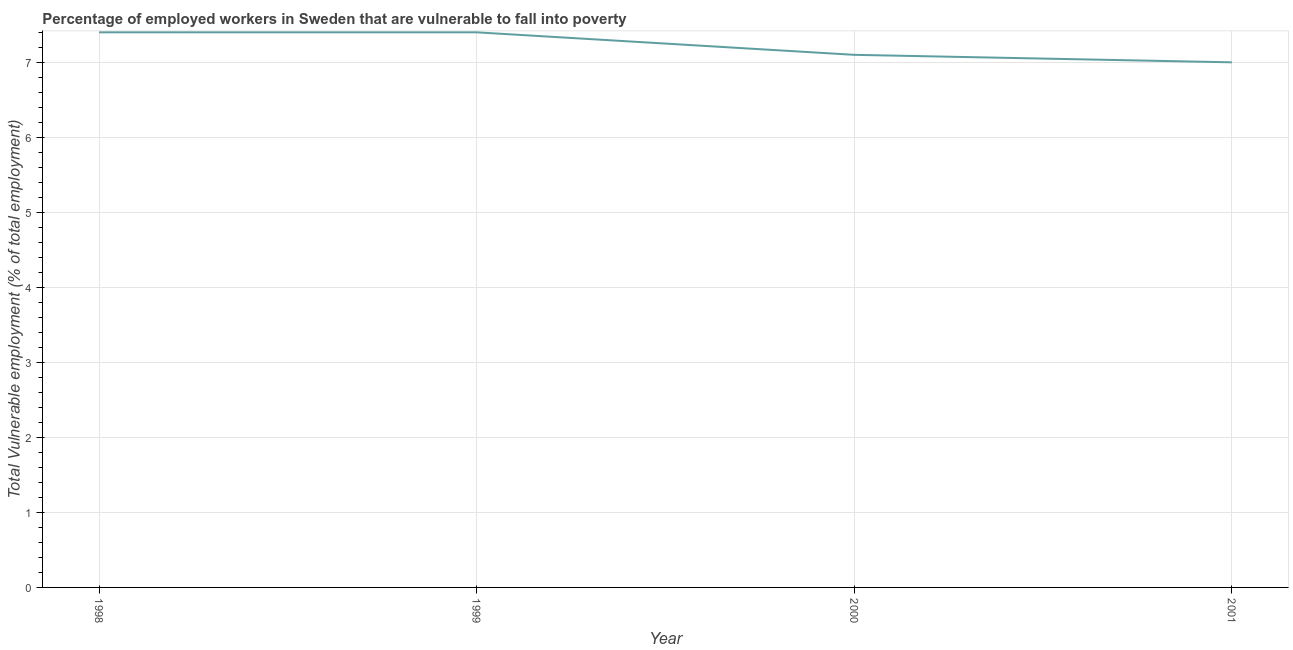What is the total vulnerable employment in 2000?
Provide a succinct answer. 7.1. Across all years, what is the maximum total vulnerable employment?
Give a very brief answer. 7.4. Across all years, what is the minimum total vulnerable employment?
Keep it short and to the point. 7. In which year was the total vulnerable employment minimum?
Your response must be concise. 2001. What is the sum of the total vulnerable employment?
Make the answer very short. 28.9. What is the difference between the total vulnerable employment in 1998 and 2000?
Make the answer very short. 0.3. What is the average total vulnerable employment per year?
Your answer should be compact. 7.23. What is the median total vulnerable employment?
Your answer should be very brief. 7.25. Do a majority of the years between 1999 and 2000 (inclusive) have total vulnerable employment greater than 2.8 %?
Provide a short and direct response. Yes. Is the difference between the total vulnerable employment in 1998 and 2001 greater than the difference between any two years?
Ensure brevity in your answer.  Yes. Is the sum of the total vulnerable employment in 2000 and 2001 greater than the maximum total vulnerable employment across all years?
Provide a succinct answer. Yes. What is the difference between the highest and the lowest total vulnerable employment?
Provide a succinct answer. 0.4. Does the total vulnerable employment monotonically increase over the years?
Provide a short and direct response. No. How many lines are there?
Your response must be concise. 1. Does the graph contain grids?
Make the answer very short. Yes. What is the title of the graph?
Your answer should be very brief. Percentage of employed workers in Sweden that are vulnerable to fall into poverty. What is the label or title of the Y-axis?
Your response must be concise. Total Vulnerable employment (% of total employment). What is the Total Vulnerable employment (% of total employment) of 1998?
Make the answer very short. 7.4. What is the Total Vulnerable employment (% of total employment) of 1999?
Provide a short and direct response. 7.4. What is the Total Vulnerable employment (% of total employment) in 2000?
Give a very brief answer. 7.1. What is the difference between the Total Vulnerable employment (% of total employment) in 1998 and 1999?
Keep it short and to the point. 0. What is the ratio of the Total Vulnerable employment (% of total employment) in 1998 to that in 2000?
Provide a short and direct response. 1.04. What is the ratio of the Total Vulnerable employment (% of total employment) in 1998 to that in 2001?
Give a very brief answer. 1.06. What is the ratio of the Total Vulnerable employment (% of total employment) in 1999 to that in 2000?
Your answer should be compact. 1.04. What is the ratio of the Total Vulnerable employment (% of total employment) in 1999 to that in 2001?
Provide a short and direct response. 1.06. 